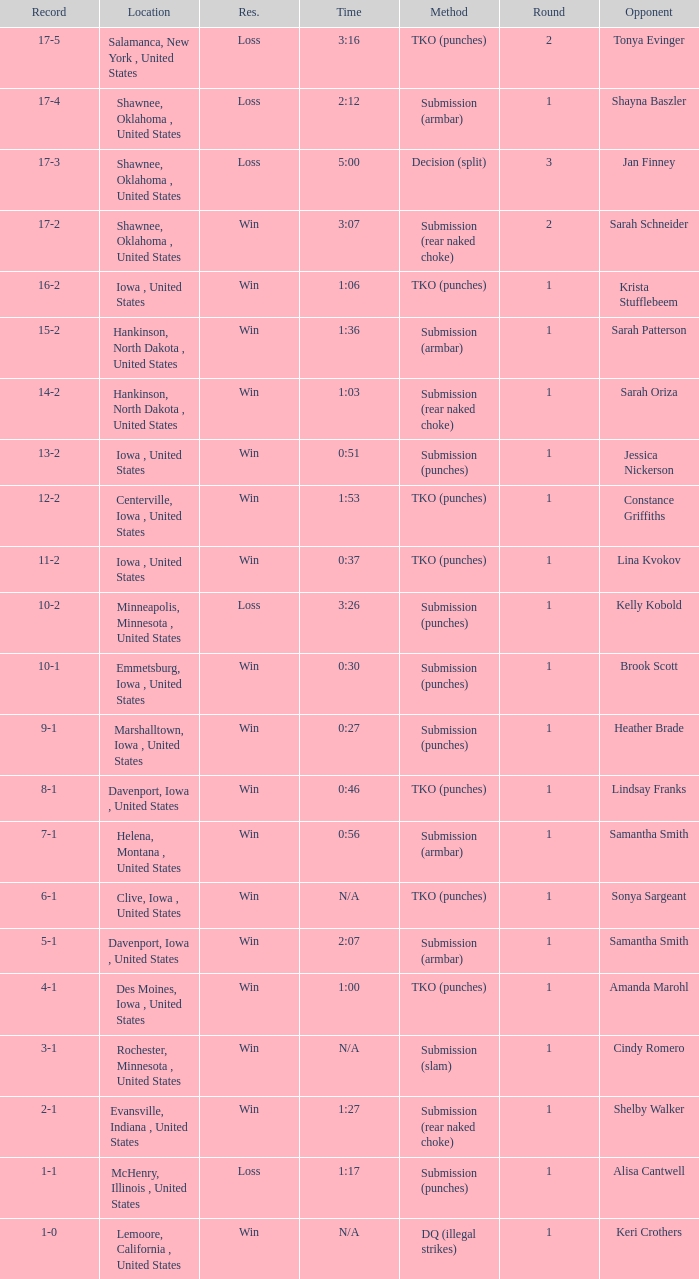What opponent does she fight when she is 10-1? Brook Scott. 